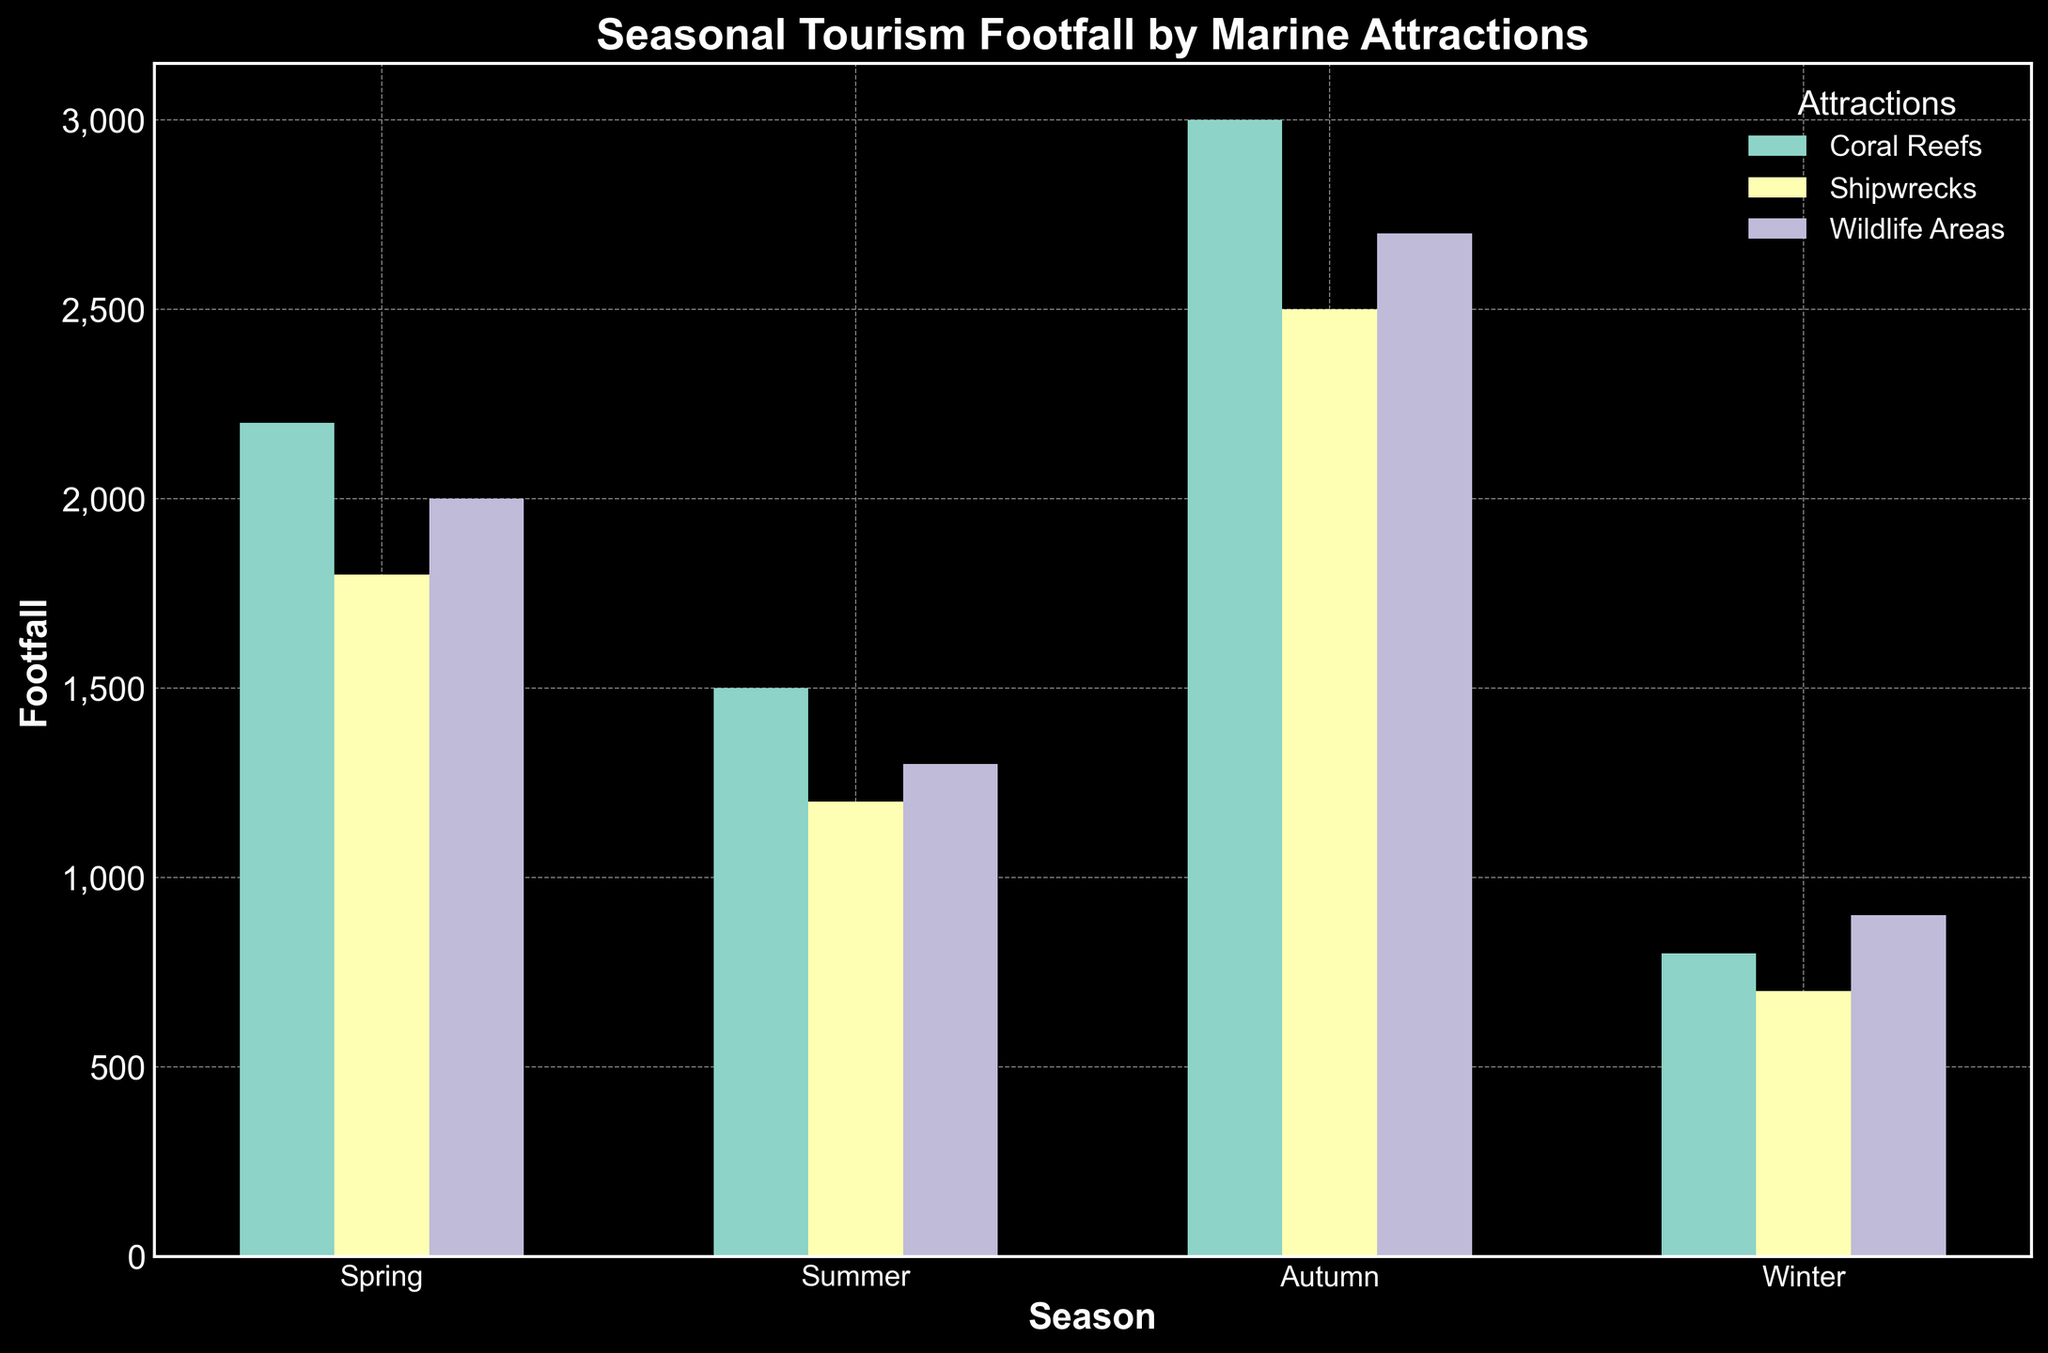Which season has the highest footfall for Coral Reefs? The bar representing summer for Coral Reefs is the tallest, indicating the highest footfall.
Answer: Summer Which marine attraction has the lowest footfall in Winter? The Shipwrecks bar in winter is the shortest among the three attractions.
Answer: Shipwrecks What is the total footfall for Wildlife Areas across all seasons? Summer: 2700, Spring: 1300, Autumn: 2000, Winter: 900. Total = 2700 + 1300 + 2000 + 900 = 6900
Answer: 6900 How does the footfall in Autumn compare between Coral Reefs and Shipwrecks? Autumn footfall is Coral Reefs: 2200, Shipwrecks: 1800. Coral Reefs have more footfall than Shipwrecks.
Answer: Coral Reefs Which season has the closest footfall numbers among all three marine attractions? In Autumn, Coral Reefs: 2200, Shipwrecks: 1800, Wildlife Areas: 2000. These values are closest to each other among all seasons.
Answer: Autumn What is the average footfall for Shipwrecks across all seasons? (Spring: 1200 + Summer: 2500 + Autumn: 1800 + Winter: 700) / 4 = (1200 + 2500 + 1800 + 700)/4 = 6200/4 = 1550
Answer: 1550 How much more is the footfall for Coral Reefs in Summer compared to Winter? Summer: 3000, Winter: 800. Difference = 3000 - 800 = 2200
Answer: 2200 Which attraction shows the largest increase in footfall from Spring to Summer? Coral Reefs increase by (3000 - 1500 = 1500), Shipwrecks by (2500 - 1200 = 1300), Wildlife Areas by (2700 - 1300 = 1400). Coral Reefs have the largest increase.
Answer: Coral Reefs What is the visual differentiation color for Wildlife Areas in the plot? The bars for Wildlife Areas are colored in orange (assuming a typical color scheme).
Answer: Orange Compare the highest footfall season for Shipwrecks and Wildlife Areas. Which has the higher value? Summer footfall: Shipwrecks = 2500, Wildlife Areas = 2700. Wildlife Areas have a higher value.
Answer: Wildlife Areas 